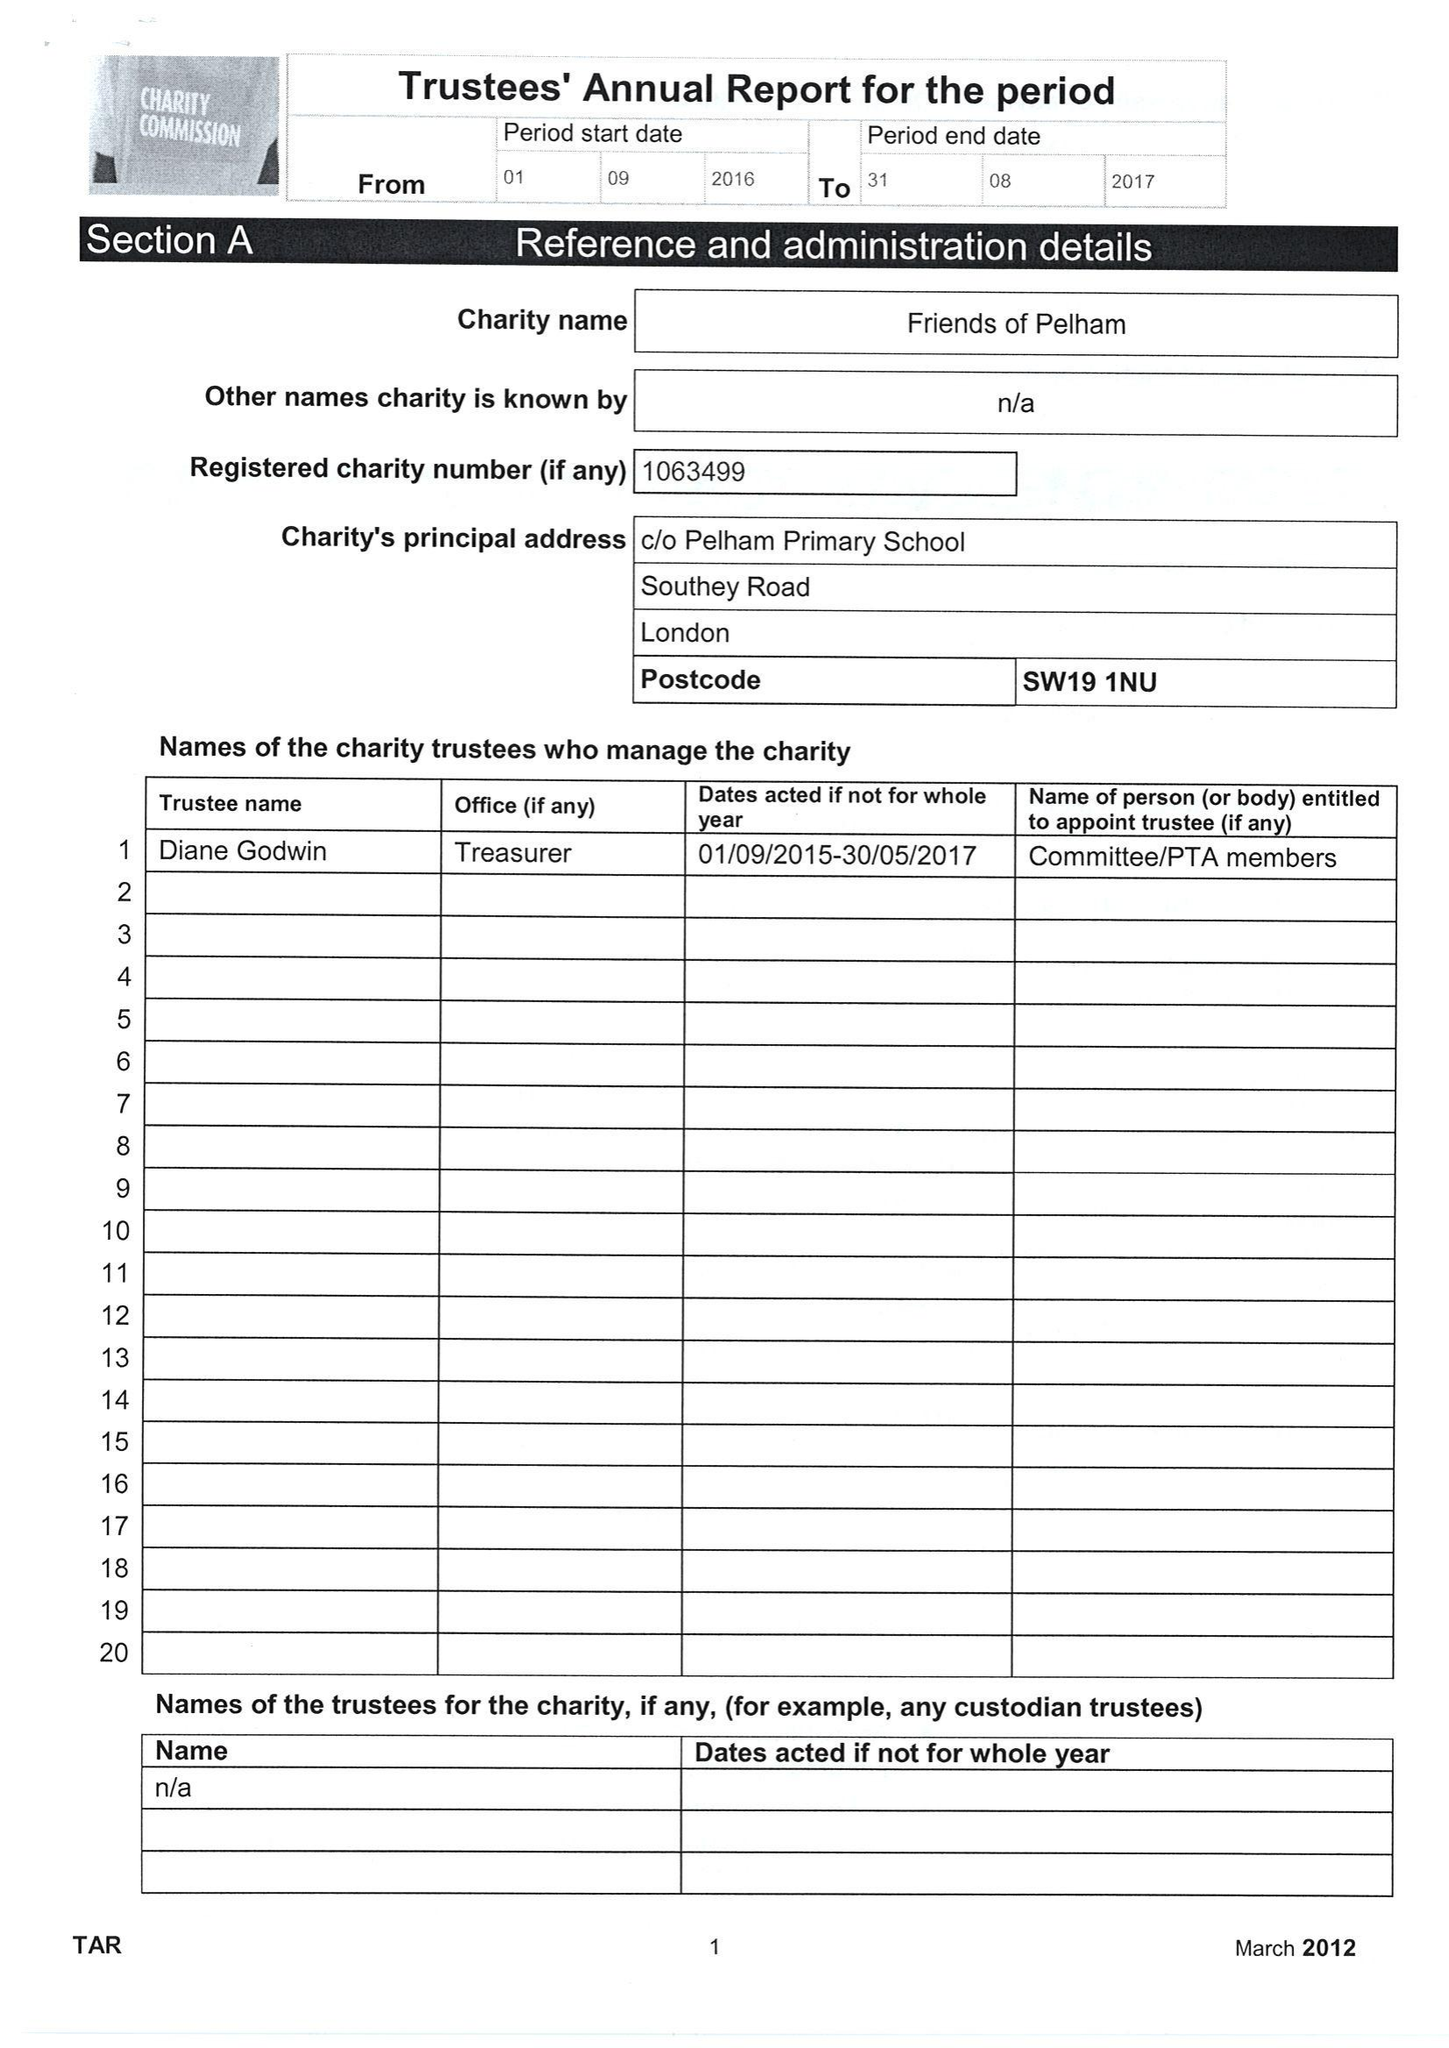What is the value for the charity_number?
Answer the question using a single word or phrase. 1063499 